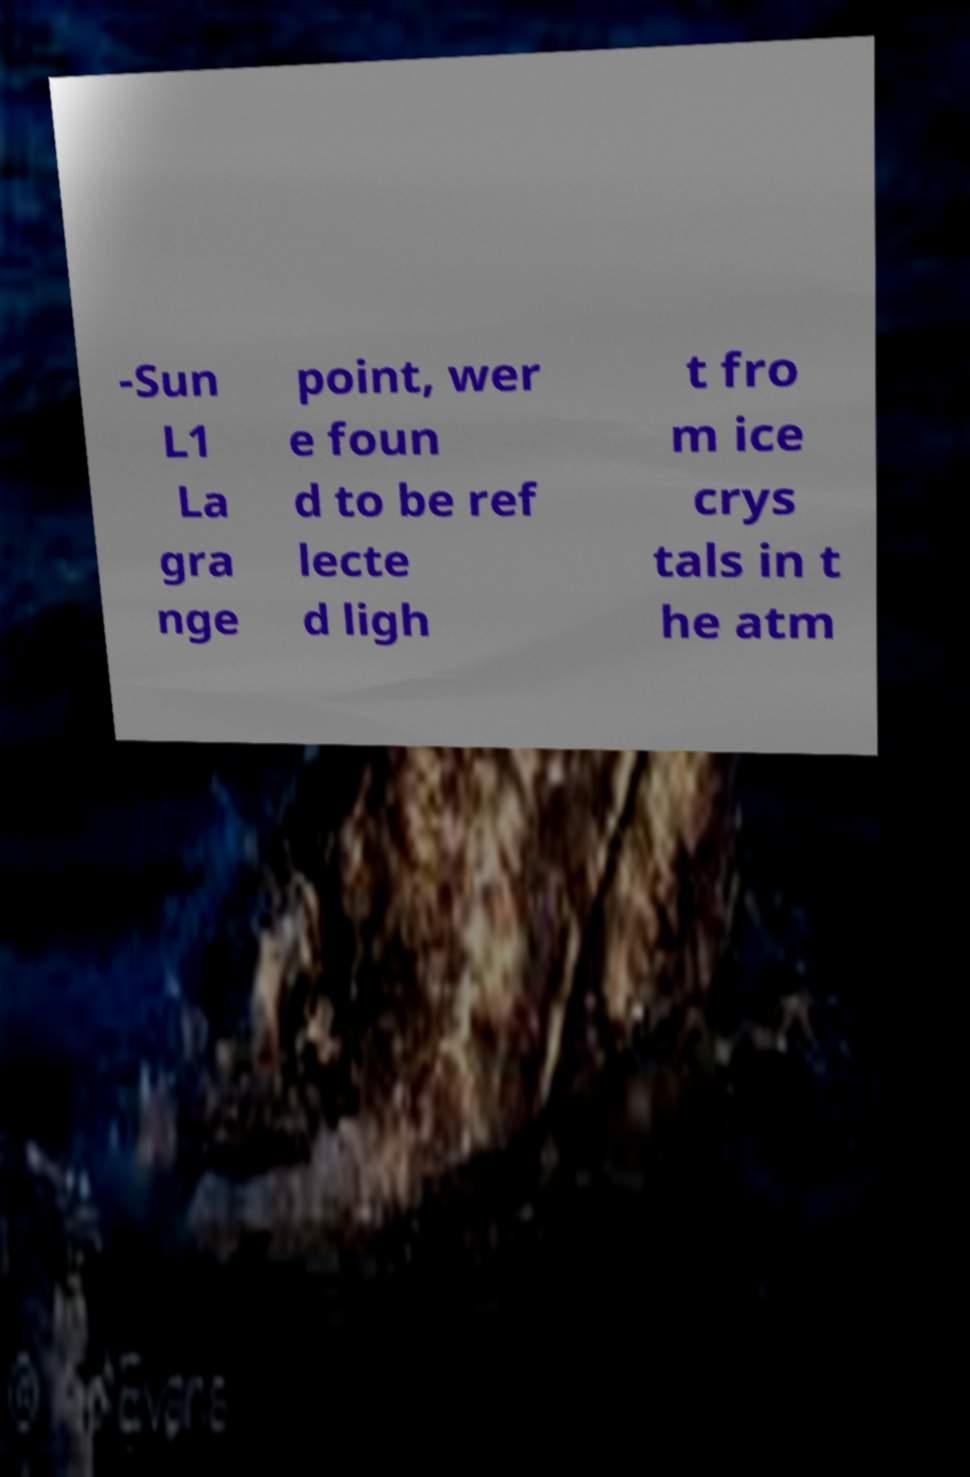Could you extract and type out the text from this image? -Sun L1 La gra nge point, wer e foun d to be ref lecte d ligh t fro m ice crys tals in t he atm 